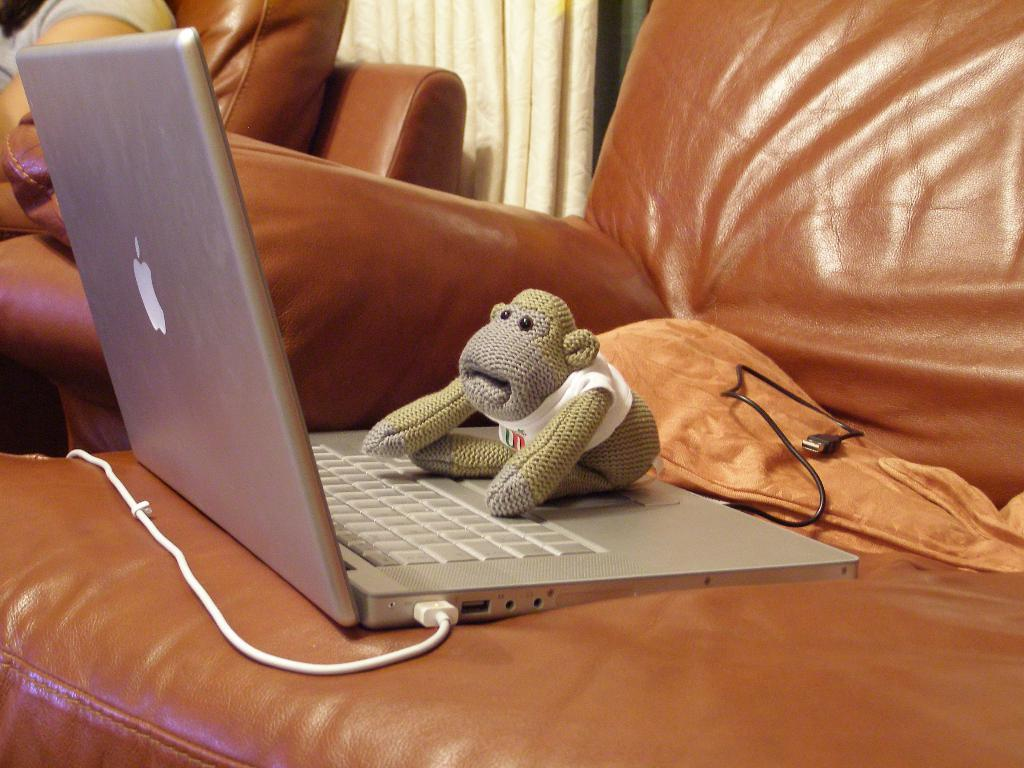What object can be seen in the image that is typically used for play or entertainment? There is a toy in the image. What electronic device is visible in the image? There is a laptop in the image. What is the laptop connected to in the image? The laptop and cable are on a couch in the image. What type of window treatment is visible in the background of the image? There is a curtain in the background of the image. Can you describe the setting where the person is sitting in the background? There is a person sitting on another couch in the background of the image. What type of scarf is the person wearing while playing basketball in the image? There is no person wearing a scarf or playing basketball in the image. 